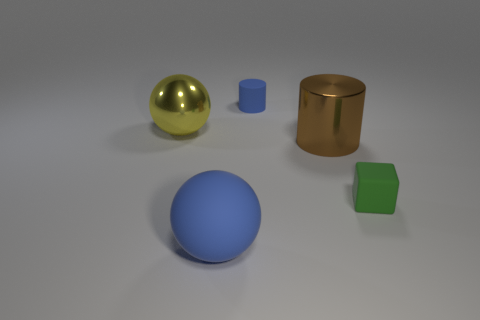Is there any indication of movement or is the setting static? The setting in the image appears static. There are no clear indications of movement, such as motion blur or objects being off-balance. Everything is resting in place, suggesting a still life scene.  How would you describe the colors in the image? The image features a fairly muted color palette. The green and blue objects provide a pop of color against the neutral background. The metallic objects reflect some of the surrounding colors, which adds a subtle touch of complexity to the overall color scheme. 